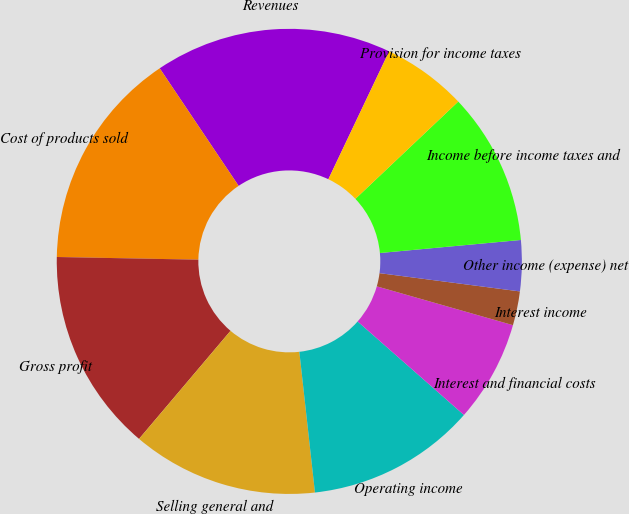Convert chart to OTSL. <chart><loc_0><loc_0><loc_500><loc_500><pie_chart><fcel>Revenues<fcel>Cost of products sold<fcel>Gross profit<fcel>Selling general and<fcel>Operating income<fcel>Interest and financial costs<fcel>Interest income<fcel>Other income (expense) net<fcel>Income before income taxes and<fcel>Provision for income taxes<nl><fcel>16.47%<fcel>15.29%<fcel>14.12%<fcel>12.94%<fcel>11.76%<fcel>7.06%<fcel>2.36%<fcel>3.53%<fcel>10.59%<fcel>5.88%<nl></chart> 